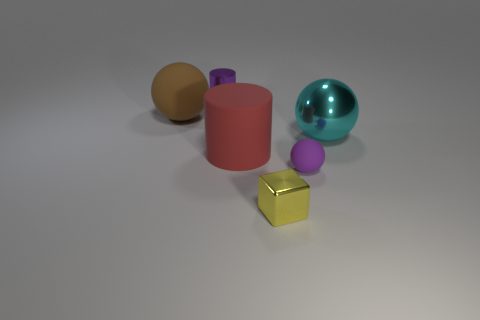Is there any other thing that is the same shape as the yellow thing?
Keep it short and to the point. No. Are there any other tiny yellow blocks that have the same material as the cube?
Provide a succinct answer. No. Are there any purple rubber spheres that are to the right of the large brown thing behind the small yellow cube?
Your answer should be compact. Yes. What material is the tiny object left of the red cylinder?
Offer a terse response. Metal. Is the shape of the large red thing the same as the small matte thing?
Ensure brevity in your answer.  No. What is the color of the small metal thing right of the metal object behind the ball that is on the left side of the metallic cube?
Your answer should be very brief. Yellow. What number of big brown things are the same shape as the large red thing?
Give a very brief answer. 0. What is the size of the purple thing that is right of the purple object behind the large brown sphere?
Keep it short and to the point. Small. Is the yellow metal object the same size as the purple metallic cylinder?
Offer a terse response. Yes. There is a cylinder behind the ball to the left of the small yellow thing; is there a purple object in front of it?
Provide a short and direct response. Yes. 